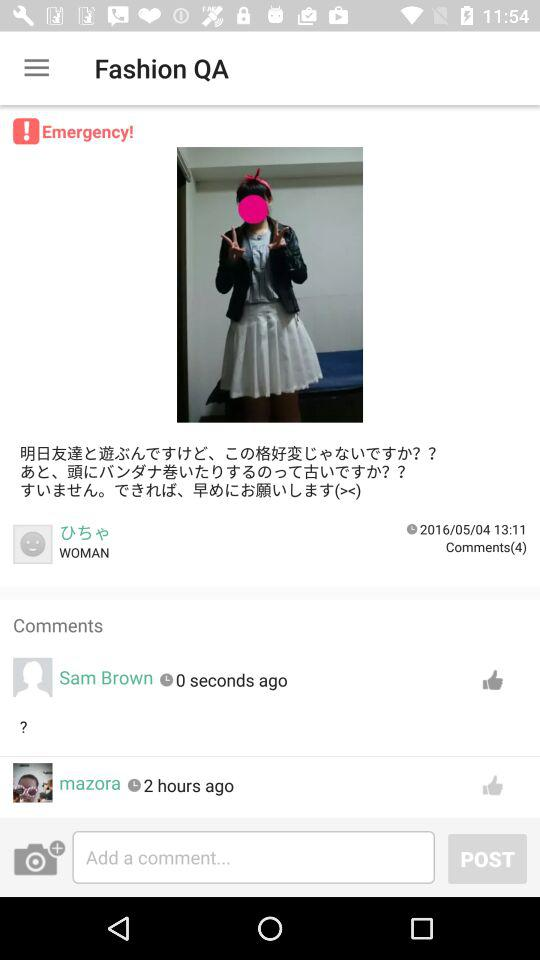How long ago did Sam Brown comment? Sam Brown commented 0 seconds ago. 